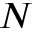<formula> <loc_0><loc_0><loc_500><loc_500>N</formula> 